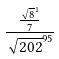Convert formula to latex. <formula><loc_0><loc_0><loc_500><loc_500>\frac { \frac { \sqrt { 8 } ^ { 1 } } { 7 } } { \sqrt { 2 0 2 } ^ { 9 5 } }</formula> 